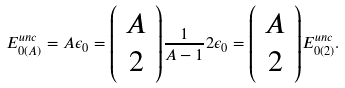Convert formula to latex. <formula><loc_0><loc_0><loc_500><loc_500>E _ { 0 ( A ) } ^ { u n c } = A \epsilon _ { 0 } = { \left ( \begin{array} { c } A \\ 2 \end{array} \right ) } \frac { 1 } { A - 1 } 2 \epsilon _ { 0 } = { \left ( \begin{array} { c } A \\ 2 \end{array} \right ) } E _ { 0 ( 2 ) } ^ { u n c } .</formula> 